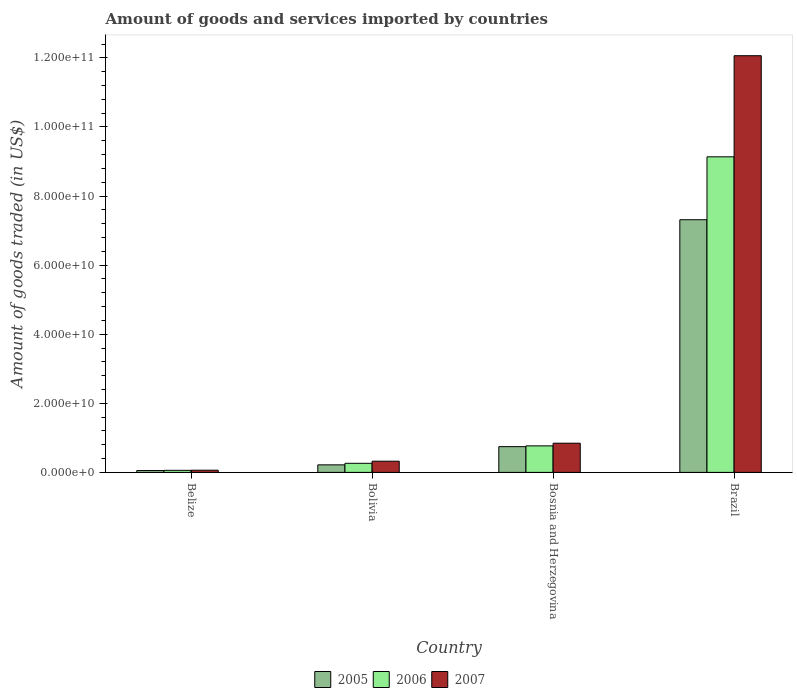How many different coloured bars are there?
Give a very brief answer. 3. Are the number of bars per tick equal to the number of legend labels?
Give a very brief answer. Yes. In how many cases, is the number of bars for a given country not equal to the number of legend labels?
Keep it short and to the point. 0. What is the total amount of goods and services imported in 2007 in Brazil?
Make the answer very short. 1.21e+11. Across all countries, what is the maximum total amount of goods and services imported in 2006?
Provide a short and direct response. 9.13e+1. Across all countries, what is the minimum total amount of goods and services imported in 2007?
Your response must be concise. 6.35e+08. In which country was the total amount of goods and services imported in 2006 minimum?
Make the answer very short. Belize. What is the total total amount of goods and services imported in 2005 in the graph?
Provide a short and direct response. 8.33e+1. What is the difference between the total amount of goods and services imported in 2006 in Bosnia and Herzegovina and that in Brazil?
Offer a terse response. -8.37e+1. What is the difference between the total amount of goods and services imported in 2006 in Bosnia and Herzegovina and the total amount of goods and services imported in 2005 in Brazil?
Ensure brevity in your answer.  -6.55e+1. What is the average total amount of goods and services imported in 2006 per country?
Your answer should be very brief. 2.56e+1. What is the difference between the total amount of goods and services imported of/in 2005 and total amount of goods and services imported of/in 2006 in Brazil?
Your response must be concise. -1.82e+1. What is the ratio of the total amount of goods and services imported in 2007 in Bolivia to that in Bosnia and Herzegovina?
Give a very brief answer. 0.38. Is the total amount of goods and services imported in 2006 in Belize less than that in Bosnia and Herzegovina?
Your answer should be very brief. Yes. Is the difference between the total amount of goods and services imported in 2005 in Belize and Bolivia greater than the difference between the total amount of goods and services imported in 2006 in Belize and Bolivia?
Ensure brevity in your answer.  Yes. What is the difference between the highest and the second highest total amount of goods and services imported in 2006?
Ensure brevity in your answer.  -8.87e+1. What is the difference between the highest and the lowest total amount of goods and services imported in 2006?
Offer a very short reply. 9.08e+1. In how many countries, is the total amount of goods and services imported in 2006 greater than the average total amount of goods and services imported in 2006 taken over all countries?
Ensure brevity in your answer.  1. Is the sum of the total amount of goods and services imported in 2006 in Bosnia and Herzegovina and Brazil greater than the maximum total amount of goods and services imported in 2007 across all countries?
Make the answer very short. No. How many bars are there?
Your answer should be compact. 12. Are all the bars in the graph horizontal?
Ensure brevity in your answer.  No. What is the difference between two consecutive major ticks on the Y-axis?
Keep it short and to the point. 2.00e+1. Does the graph contain any zero values?
Keep it short and to the point. No. Where does the legend appear in the graph?
Keep it short and to the point. Bottom center. What is the title of the graph?
Offer a terse response. Amount of goods and services imported by countries. What is the label or title of the X-axis?
Your answer should be very brief. Country. What is the label or title of the Y-axis?
Your answer should be very brief. Amount of goods traded (in US$). What is the Amount of goods traded (in US$) of 2005 in Belize?
Offer a very short reply. 5.44e+08. What is the Amount of goods traded (in US$) in 2006 in Belize?
Provide a succinct answer. 5.98e+08. What is the Amount of goods traded (in US$) in 2007 in Belize?
Offer a very short reply. 6.35e+08. What is the Amount of goods traded (in US$) of 2005 in Bolivia?
Provide a short and direct response. 2.18e+09. What is the Amount of goods traded (in US$) in 2006 in Bolivia?
Keep it short and to the point. 2.63e+09. What is the Amount of goods traded (in US$) of 2007 in Bolivia?
Give a very brief answer. 3.24e+09. What is the Amount of goods traded (in US$) in 2005 in Bosnia and Herzegovina?
Your response must be concise. 7.45e+09. What is the Amount of goods traded (in US$) of 2006 in Bosnia and Herzegovina?
Your response must be concise. 7.68e+09. What is the Amount of goods traded (in US$) of 2007 in Bosnia and Herzegovina?
Make the answer very short. 8.45e+09. What is the Amount of goods traded (in US$) of 2005 in Brazil?
Offer a very short reply. 7.31e+1. What is the Amount of goods traded (in US$) of 2006 in Brazil?
Give a very brief answer. 9.13e+1. What is the Amount of goods traded (in US$) of 2007 in Brazil?
Keep it short and to the point. 1.21e+11. Across all countries, what is the maximum Amount of goods traded (in US$) in 2005?
Give a very brief answer. 7.31e+1. Across all countries, what is the maximum Amount of goods traded (in US$) in 2006?
Ensure brevity in your answer.  9.13e+1. Across all countries, what is the maximum Amount of goods traded (in US$) in 2007?
Your answer should be compact. 1.21e+11. Across all countries, what is the minimum Amount of goods traded (in US$) in 2005?
Keep it short and to the point. 5.44e+08. Across all countries, what is the minimum Amount of goods traded (in US$) in 2006?
Make the answer very short. 5.98e+08. Across all countries, what is the minimum Amount of goods traded (in US$) in 2007?
Offer a very short reply. 6.35e+08. What is the total Amount of goods traded (in US$) in 2005 in the graph?
Your answer should be very brief. 8.33e+1. What is the total Amount of goods traded (in US$) in 2006 in the graph?
Your response must be concise. 1.02e+11. What is the total Amount of goods traded (in US$) of 2007 in the graph?
Give a very brief answer. 1.33e+11. What is the difference between the Amount of goods traded (in US$) of 2005 in Belize and that in Bolivia?
Your answer should be compact. -1.64e+09. What is the difference between the Amount of goods traded (in US$) in 2006 in Belize and that in Bolivia?
Keep it short and to the point. -2.03e+09. What is the difference between the Amount of goods traded (in US$) of 2007 in Belize and that in Bolivia?
Provide a short and direct response. -2.61e+09. What is the difference between the Amount of goods traded (in US$) in 2005 in Belize and that in Bosnia and Herzegovina?
Your answer should be compact. -6.91e+09. What is the difference between the Amount of goods traded (in US$) in 2006 in Belize and that in Bosnia and Herzegovina?
Keep it short and to the point. -7.08e+09. What is the difference between the Amount of goods traded (in US$) of 2007 in Belize and that in Bosnia and Herzegovina?
Offer a very short reply. -7.82e+09. What is the difference between the Amount of goods traded (in US$) of 2005 in Belize and that in Brazil?
Offer a terse response. -7.26e+1. What is the difference between the Amount of goods traded (in US$) in 2006 in Belize and that in Brazil?
Your answer should be very brief. -9.08e+1. What is the difference between the Amount of goods traded (in US$) of 2007 in Belize and that in Brazil?
Keep it short and to the point. -1.20e+11. What is the difference between the Amount of goods traded (in US$) in 2005 in Bolivia and that in Bosnia and Herzegovina?
Provide a short and direct response. -5.27e+09. What is the difference between the Amount of goods traded (in US$) of 2006 in Bolivia and that in Bosnia and Herzegovina?
Make the answer very short. -5.05e+09. What is the difference between the Amount of goods traded (in US$) of 2007 in Bolivia and that in Bosnia and Herzegovina?
Your answer should be very brief. -5.21e+09. What is the difference between the Amount of goods traded (in US$) of 2005 in Bolivia and that in Brazil?
Your answer should be very brief. -7.10e+1. What is the difference between the Amount of goods traded (in US$) of 2006 in Bolivia and that in Brazil?
Offer a terse response. -8.87e+1. What is the difference between the Amount of goods traded (in US$) in 2007 in Bolivia and that in Brazil?
Your answer should be very brief. -1.17e+11. What is the difference between the Amount of goods traded (in US$) of 2005 in Bosnia and Herzegovina and that in Brazil?
Your response must be concise. -6.57e+1. What is the difference between the Amount of goods traded (in US$) in 2006 in Bosnia and Herzegovina and that in Brazil?
Provide a short and direct response. -8.37e+1. What is the difference between the Amount of goods traded (in US$) in 2007 in Bosnia and Herzegovina and that in Brazil?
Your response must be concise. -1.12e+11. What is the difference between the Amount of goods traded (in US$) in 2005 in Belize and the Amount of goods traded (in US$) in 2006 in Bolivia?
Your answer should be compact. -2.09e+09. What is the difference between the Amount of goods traded (in US$) of 2005 in Belize and the Amount of goods traded (in US$) of 2007 in Bolivia?
Your answer should be very brief. -2.70e+09. What is the difference between the Amount of goods traded (in US$) in 2006 in Belize and the Amount of goods traded (in US$) in 2007 in Bolivia?
Your answer should be very brief. -2.65e+09. What is the difference between the Amount of goods traded (in US$) in 2005 in Belize and the Amount of goods traded (in US$) in 2006 in Bosnia and Herzegovina?
Keep it short and to the point. -7.14e+09. What is the difference between the Amount of goods traded (in US$) of 2005 in Belize and the Amount of goods traded (in US$) of 2007 in Bosnia and Herzegovina?
Your answer should be compact. -7.91e+09. What is the difference between the Amount of goods traded (in US$) in 2006 in Belize and the Amount of goods traded (in US$) in 2007 in Bosnia and Herzegovina?
Ensure brevity in your answer.  -7.86e+09. What is the difference between the Amount of goods traded (in US$) of 2005 in Belize and the Amount of goods traded (in US$) of 2006 in Brazil?
Your answer should be compact. -9.08e+1. What is the difference between the Amount of goods traded (in US$) of 2005 in Belize and the Amount of goods traded (in US$) of 2007 in Brazil?
Provide a short and direct response. -1.20e+11. What is the difference between the Amount of goods traded (in US$) in 2006 in Belize and the Amount of goods traded (in US$) in 2007 in Brazil?
Your answer should be very brief. -1.20e+11. What is the difference between the Amount of goods traded (in US$) of 2005 in Bolivia and the Amount of goods traded (in US$) of 2006 in Bosnia and Herzegovina?
Your response must be concise. -5.50e+09. What is the difference between the Amount of goods traded (in US$) in 2005 in Bolivia and the Amount of goods traded (in US$) in 2007 in Bosnia and Herzegovina?
Offer a terse response. -6.27e+09. What is the difference between the Amount of goods traded (in US$) of 2006 in Bolivia and the Amount of goods traded (in US$) of 2007 in Bosnia and Herzegovina?
Offer a very short reply. -5.82e+09. What is the difference between the Amount of goods traded (in US$) in 2005 in Bolivia and the Amount of goods traded (in US$) in 2006 in Brazil?
Offer a very short reply. -8.92e+1. What is the difference between the Amount of goods traded (in US$) in 2005 in Bolivia and the Amount of goods traded (in US$) in 2007 in Brazil?
Offer a terse response. -1.18e+11. What is the difference between the Amount of goods traded (in US$) in 2006 in Bolivia and the Amount of goods traded (in US$) in 2007 in Brazil?
Make the answer very short. -1.18e+11. What is the difference between the Amount of goods traded (in US$) of 2005 in Bosnia and Herzegovina and the Amount of goods traded (in US$) of 2006 in Brazil?
Keep it short and to the point. -8.39e+1. What is the difference between the Amount of goods traded (in US$) of 2005 in Bosnia and Herzegovina and the Amount of goods traded (in US$) of 2007 in Brazil?
Your answer should be very brief. -1.13e+11. What is the difference between the Amount of goods traded (in US$) in 2006 in Bosnia and Herzegovina and the Amount of goods traded (in US$) in 2007 in Brazil?
Make the answer very short. -1.13e+11. What is the average Amount of goods traded (in US$) in 2005 per country?
Your answer should be very brief. 2.08e+1. What is the average Amount of goods traded (in US$) in 2006 per country?
Offer a very short reply. 2.56e+1. What is the average Amount of goods traded (in US$) of 2007 per country?
Provide a succinct answer. 3.32e+1. What is the difference between the Amount of goods traded (in US$) in 2005 and Amount of goods traded (in US$) in 2006 in Belize?
Your answer should be very brief. -5.37e+07. What is the difference between the Amount of goods traded (in US$) of 2005 and Amount of goods traded (in US$) of 2007 in Belize?
Ensure brevity in your answer.  -9.05e+07. What is the difference between the Amount of goods traded (in US$) in 2006 and Amount of goods traded (in US$) in 2007 in Belize?
Offer a very short reply. -3.68e+07. What is the difference between the Amount of goods traded (in US$) in 2005 and Amount of goods traded (in US$) in 2006 in Bolivia?
Offer a terse response. -4.50e+08. What is the difference between the Amount of goods traded (in US$) in 2005 and Amount of goods traded (in US$) in 2007 in Bolivia?
Provide a succinct answer. -1.06e+09. What is the difference between the Amount of goods traded (in US$) in 2006 and Amount of goods traded (in US$) in 2007 in Bolivia?
Make the answer very short. -6.11e+08. What is the difference between the Amount of goods traded (in US$) in 2005 and Amount of goods traded (in US$) in 2006 in Bosnia and Herzegovina?
Keep it short and to the point. -2.25e+08. What is the difference between the Amount of goods traded (in US$) in 2005 and Amount of goods traded (in US$) in 2007 in Bosnia and Herzegovina?
Provide a succinct answer. -1.00e+09. What is the difference between the Amount of goods traded (in US$) of 2006 and Amount of goods traded (in US$) of 2007 in Bosnia and Herzegovina?
Ensure brevity in your answer.  -7.75e+08. What is the difference between the Amount of goods traded (in US$) in 2005 and Amount of goods traded (in US$) in 2006 in Brazil?
Your response must be concise. -1.82e+1. What is the difference between the Amount of goods traded (in US$) in 2005 and Amount of goods traded (in US$) in 2007 in Brazil?
Give a very brief answer. -4.75e+1. What is the difference between the Amount of goods traded (in US$) of 2006 and Amount of goods traded (in US$) of 2007 in Brazil?
Give a very brief answer. -2.93e+1. What is the ratio of the Amount of goods traded (in US$) in 2005 in Belize to that in Bolivia?
Provide a succinct answer. 0.25. What is the ratio of the Amount of goods traded (in US$) in 2006 in Belize to that in Bolivia?
Your answer should be very brief. 0.23. What is the ratio of the Amount of goods traded (in US$) of 2007 in Belize to that in Bolivia?
Offer a terse response. 0.2. What is the ratio of the Amount of goods traded (in US$) of 2005 in Belize to that in Bosnia and Herzegovina?
Provide a short and direct response. 0.07. What is the ratio of the Amount of goods traded (in US$) in 2006 in Belize to that in Bosnia and Herzegovina?
Provide a succinct answer. 0.08. What is the ratio of the Amount of goods traded (in US$) of 2007 in Belize to that in Bosnia and Herzegovina?
Make the answer very short. 0.08. What is the ratio of the Amount of goods traded (in US$) in 2005 in Belize to that in Brazil?
Make the answer very short. 0.01. What is the ratio of the Amount of goods traded (in US$) of 2006 in Belize to that in Brazil?
Your response must be concise. 0.01. What is the ratio of the Amount of goods traded (in US$) in 2007 in Belize to that in Brazil?
Your answer should be very brief. 0.01. What is the ratio of the Amount of goods traded (in US$) in 2005 in Bolivia to that in Bosnia and Herzegovina?
Your response must be concise. 0.29. What is the ratio of the Amount of goods traded (in US$) in 2006 in Bolivia to that in Bosnia and Herzegovina?
Keep it short and to the point. 0.34. What is the ratio of the Amount of goods traded (in US$) in 2007 in Bolivia to that in Bosnia and Herzegovina?
Offer a very short reply. 0.38. What is the ratio of the Amount of goods traded (in US$) in 2005 in Bolivia to that in Brazil?
Provide a succinct answer. 0.03. What is the ratio of the Amount of goods traded (in US$) in 2006 in Bolivia to that in Brazil?
Give a very brief answer. 0.03. What is the ratio of the Amount of goods traded (in US$) of 2007 in Bolivia to that in Brazil?
Your answer should be compact. 0.03. What is the ratio of the Amount of goods traded (in US$) of 2005 in Bosnia and Herzegovina to that in Brazil?
Keep it short and to the point. 0.1. What is the ratio of the Amount of goods traded (in US$) in 2006 in Bosnia and Herzegovina to that in Brazil?
Give a very brief answer. 0.08. What is the ratio of the Amount of goods traded (in US$) in 2007 in Bosnia and Herzegovina to that in Brazil?
Provide a succinct answer. 0.07. What is the difference between the highest and the second highest Amount of goods traded (in US$) in 2005?
Provide a succinct answer. 6.57e+1. What is the difference between the highest and the second highest Amount of goods traded (in US$) of 2006?
Provide a short and direct response. 8.37e+1. What is the difference between the highest and the second highest Amount of goods traded (in US$) of 2007?
Provide a succinct answer. 1.12e+11. What is the difference between the highest and the lowest Amount of goods traded (in US$) in 2005?
Your response must be concise. 7.26e+1. What is the difference between the highest and the lowest Amount of goods traded (in US$) in 2006?
Ensure brevity in your answer.  9.08e+1. What is the difference between the highest and the lowest Amount of goods traded (in US$) in 2007?
Offer a very short reply. 1.20e+11. 